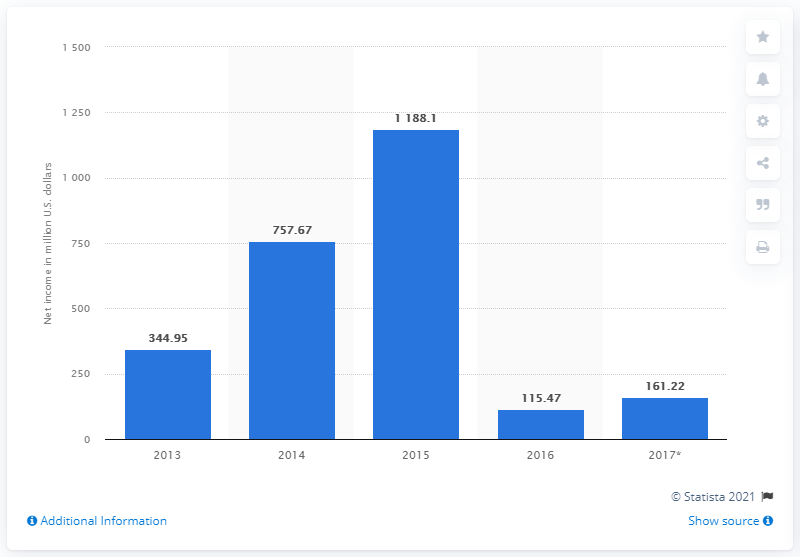Mention a couple of crucial points in this snapshot. In 2017, the global net income of JBS was 161.22 million. 